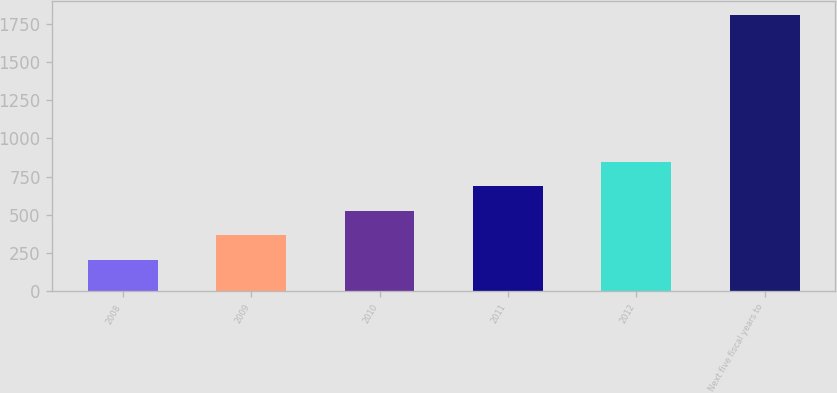<chart> <loc_0><loc_0><loc_500><loc_500><bar_chart><fcel>2008<fcel>2009<fcel>2010<fcel>2011<fcel>2012<fcel>Next five fiscal years to<nl><fcel>204<fcel>364.5<fcel>525<fcel>685.5<fcel>846<fcel>1809<nl></chart> 